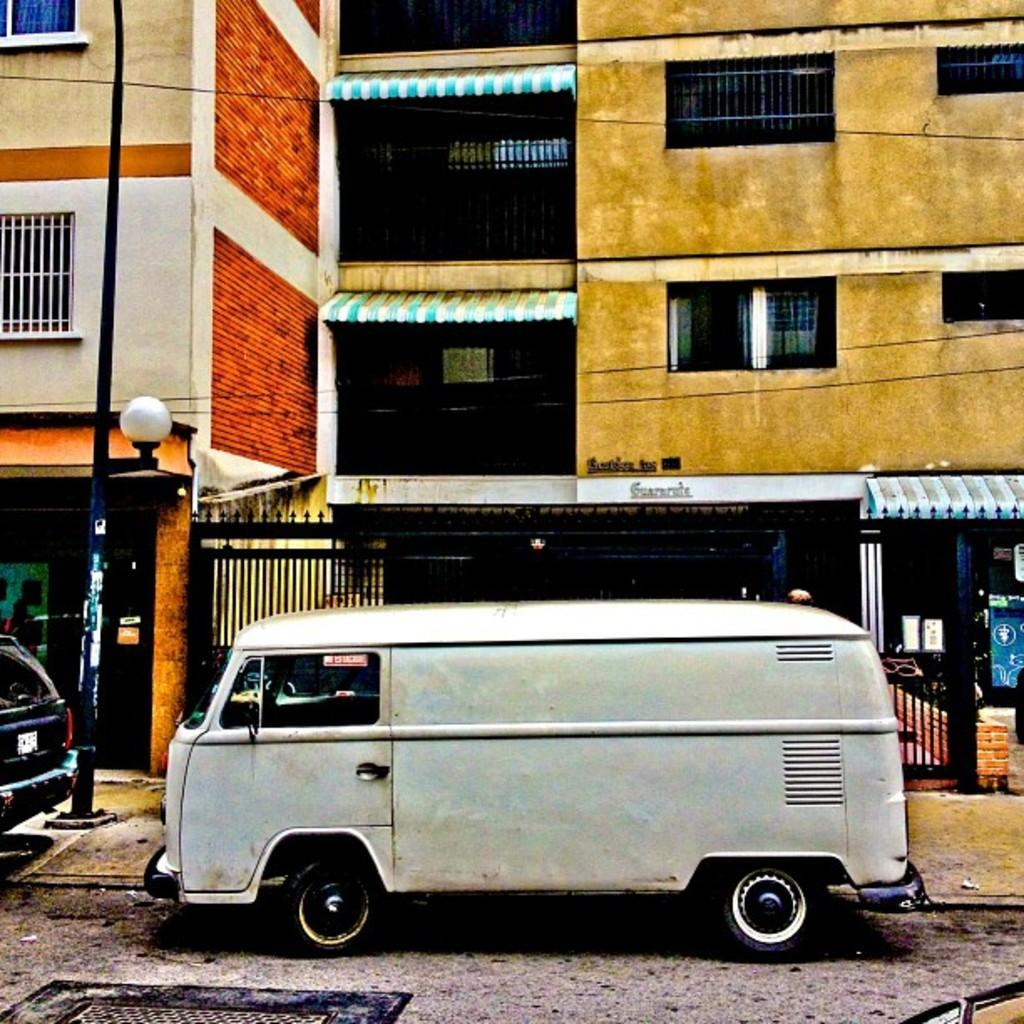What can be seen moving on the road in the image? There are vehicles on the road in the image. What is located beside the vehicles on the road? There is a pole beside the vehicles. What type of structures can be seen in the image? There are buildings visible in the image. What kind of illumination is present in the image? There is a light in the image. What type of door can be seen in the image? There is a metal door in the image. Can you tell me how many leaves are on the metal door in the image? There are no leaves present on the metal door in the image. Who is the expert in the image? There is no expert depicted in the image. 